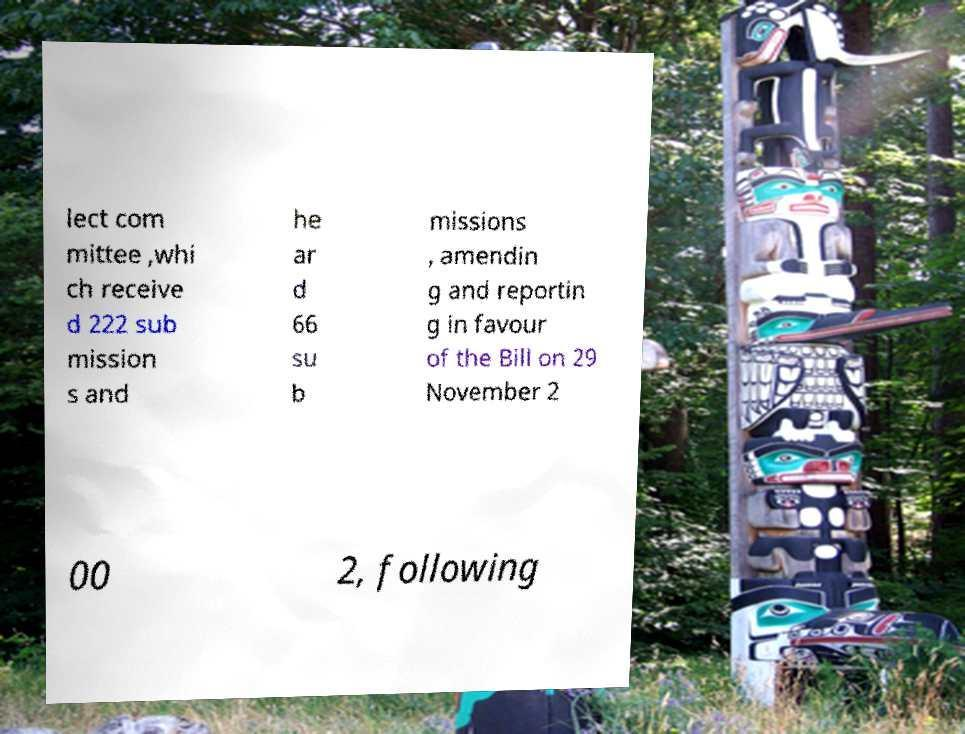For documentation purposes, I need the text within this image transcribed. Could you provide that? lect com mittee ,whi ch receive d 222 sub mission s and he ar d 66 su b missions , amendin g and reportin g in favour of the Bill on 29 November 2 00 2, following 